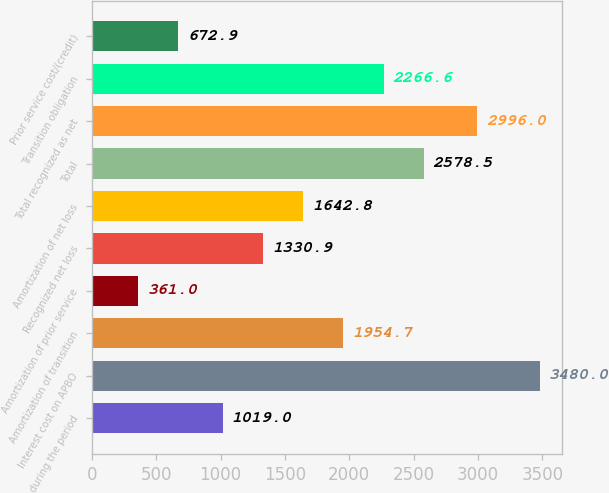Convert chart. <chart><loc_0><loc_0><loc_500><loc_500><bar_chart><fcel>during the period<fcel>Interest cost on APBO<fcel>Amortization of transition<fcel>Amortization of prior service<fcel>Recognized net loss<fcel>Amortization of net loss<fcel>Total<fcel>Total recognized as net<fcel>Transition obligation<fcel>Prior service cost/(credit)<nl><fcel>1019<fcel>3480<fcel>1954.7<fcel>361<fcel>1330.9<fcel>1642.8<fcel>2578.5<fcel>2996<fcel>2266.6<fcel>672.9<nl></chart> 